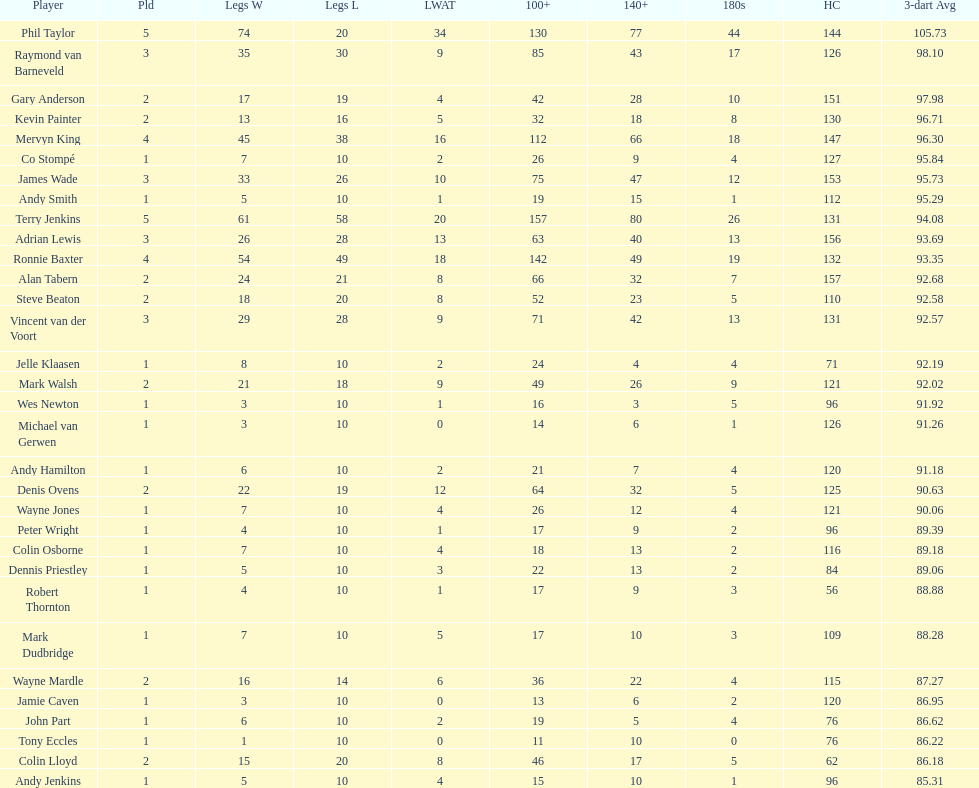What were the total number of legs won by ronnie baxter? 54. I'm looking to parse the entire table for insights. Could you assist me with that? {'header': ['Player', 'Pld', 'Legs W', 'Legs L', 'LWAT', '100+', '140+', '180s', 'HC', '3-dart Avg'], 'rows': [['Phil Taylor', '5', '74', '20', '34', '130', '77', '44', '144', '105.73'], ['Raymond van Barneveld', '3', '35', '30', '9', '85', '43', '17', '126', '98.10'], ['Gary Anderson', '2', '17', '19', '4', '42', '28', '10', '151', '97.98'], ['Kevin Painter', '2', '13', '16', '5', '32', '18', '8', '130', '96.71'], ['Mervyn King', '4', '45', '38', '16', '112', '66', '18', '147', '96.30'], ['Co Stompé', '1', '7', '10', '2', '26', '9', '4', '127', '95.84'], ['James Wade', '3', '33', '26', '10', '75', '47', '12', '153', '95.73'], ['Andy Smith', '1', '5', '10', '1', '19', '15', '1', '112', '95.29'], ['Terry Jenkins', '5', '61', '58', '20', '157', '80', '26', '131', '94.08'], ['Adrian Lewis', '3', '26', '28', '13', '63', '40', '13', '156', '93.69'], ['Ronnie Baxter', '4', '54', '49', '18', '142', '49', '19', '132', '93.35'], ['Alan Tabern', '2', '24', '21', '8', '66', '32', '7', '157', '92.68'], ['Steve Beaton', '2', '18', '20', '8', '52', '23', '5', '110', '92.58'], ['Vincent van der Voort', '3', '29', '28', '9', '71', '42', '13', '131', '92.57'], ['Jelle Klaasen', '1', '8', '10', '2', '24', '4', '4', '71', '92.19'], ['Mark Walsh', '2', '21', '18', '9', '49', '26', '9', '121', '92.02'], ['Wes Newton', '1', '3', '10', '1', '16', '3', '5', '96', '91.92'], ['Michael van Gerwen', '1', '3', '10', '0', '14', '6', '1', '126', '91.26'], ['Andy Hamilton', '1', '6', '10', '2', '21', '7', '4', '120', '91.18'], ['Denis Ovens', '2', '22', '19', '12', '64', '32', '5', '125', '90.63'], ['Wayne Jones', '1', '7', '10', '4', '26', '12', '4', '121', '90.06'], ['Peter Wright', '1', '4', '10', '1', '17', '9', '2', '96', '89.39'], ['Colin Osborne', '1', '7', '10', '4', '18', '13', '2', '116', '89.18'], ['Dennis Priestley', '1', '5', '10', '3', '22', '13', '2', '84', '89.06'], ['Robert Thornton', '1', '4', '10', '1', '17', '9', '3', '56', '88.88'], ['Mark Dudbridge', '1', '7', '10', '5', '17', '10', '3', '109', '88.28'], ['Wayne Mardle', '2', '16', '14', '6', '36', '22', '4', '115', '87.27'], ['Jamie Caven', '1', '3', '10', '0', '13', '6', '2', '120', '86.95'], ['John Part', '1', '6', '10', '2', '19', '5', '4', '76', '86.62'], ['Tony Eccles', '1', '1', '10', '0', '11', '10', '0', '76', '86.22'], ['Colin Lloyd', '2', '15', '20', '8', '46', '17', '5', '62', '86.18'], ['Andy Jenkins', '1', '5', '10', '4', '15', '10', '1', '96', '85.31']]} 